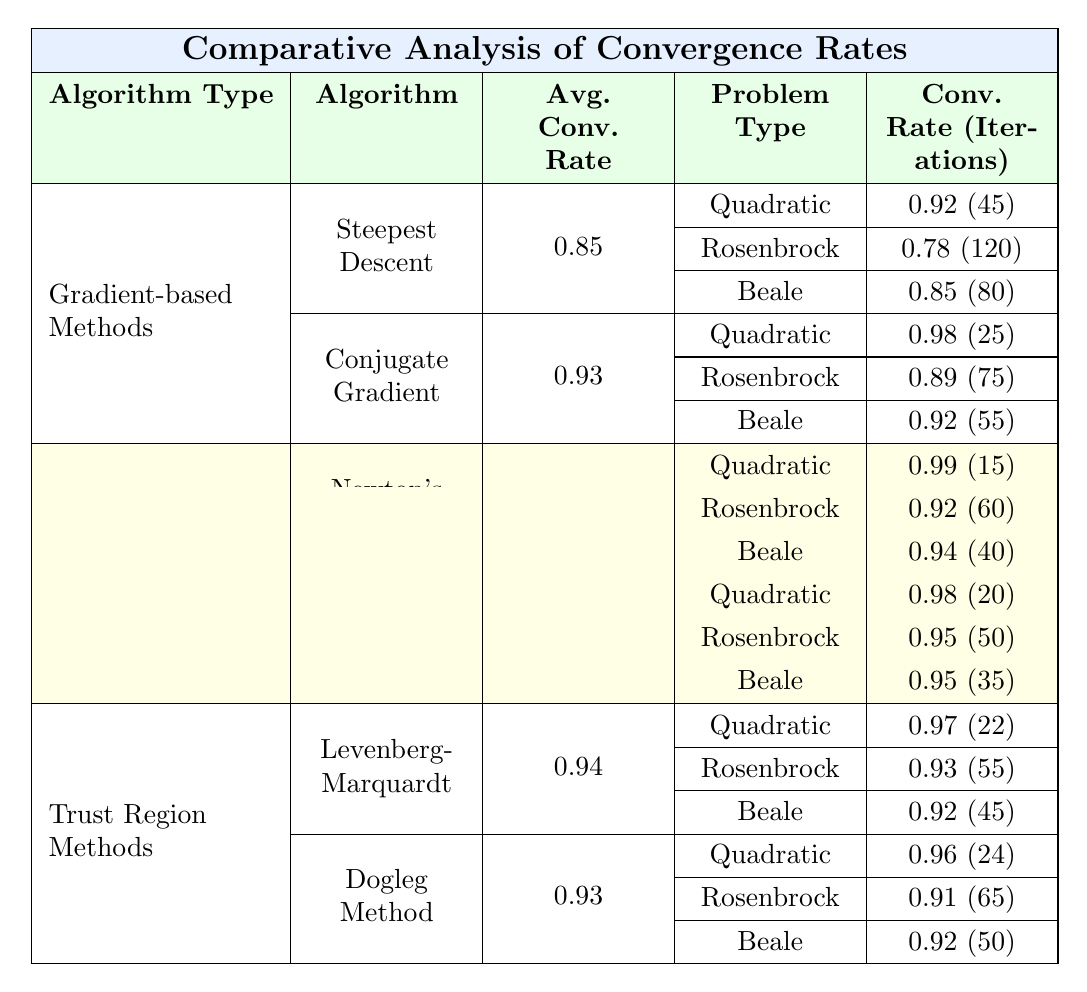What is the average convergence rate for the Conjugate Gradient method? The average convergence rate for the Conjugate Gradient method is listed in the table as 0.93.
Answer: 0.93 Which optimization algorithm has the highest average convergence rate? Comparing the average convergence rates in the table, Newton's Method has the highest value at 0.95, followed closely by BFGS at 0.96. In fact, BFGS has a higher average rate than both Gradient-based and Trust Region methods.
Answer: BFGS How many iterations does the Steepest Descent method need for the Rosenbrock function? The table shows that the Steepest Descent method requires 120 iterations to converge on the Rosenbrock function.
Answer: 120 For which problem type does the Dogleg Method converge the fastest? The table provides the convergence rates and iterations for the Dogleg Method across different problem types. It converges fastest on Quadratic Functions, requiring only 24 iterations.
Answer: Quadratic Functions Is the average convergence rate for Newton's Method higher than that of the Dogleg Method? The table shows that the average convergence rate for Newton's Method is 0.95, while for the Dogleg Method it is 0.93. Therefore, Newton's Method has a higher average convergence rate.
Answer: Yes Calculate the difference in average convergence rates between BFGS and Steepest Descent. BFGS has an average convergence rate of 0.96, while Steepest Descent has 0.85. The difference is calculated as 0.96 - 0.85 = 0.11.
Answer: 0.11 Which algorithm type shows better convergence rates on the Beale function: Gradient-based Methods or Trust Region Methods? By comparing the convergence rates for Beale function in both algorithm types, the Gradient-based Methods have a convergence rate of 0.85 for Steepest Descent and 0.92 for Conjugate Gradient. The Trust Region Methods show 0.92 for Levenberg-Marquardt and 0.92 for Dogleg Method. Thus, both algorithm types perform equally on the Beale function.
Answer: Equal Which algorithm requires the fewest iterations overall across all problem types? Analyzing the iterations, Newton's Method requires the fewest iterations on the Quadratic Function (15), indicating it may often be the most efficient. However, we need to consider all iterations across all problem types. When looking at all algorithms, the minimum is 15 iterations by Newton's Method on Quadratic Functions.
Answer: Newton's Method Does the Conjugate Gradient outperform the Steepest Descent for all problem types? The table shows that for Quadratic Functions and Beale Function, Conjugate Gradient outperforms Steepest Descent with higher convergence rates and fewer iterations. However, the Steepest Descent has a higher rate (0.85) for Beale while requiring more iterations (80 compared to 55). Therefore, Conjugate Gradient outperforms Steepest Descent for most problem types, but not all.
Answer: No 